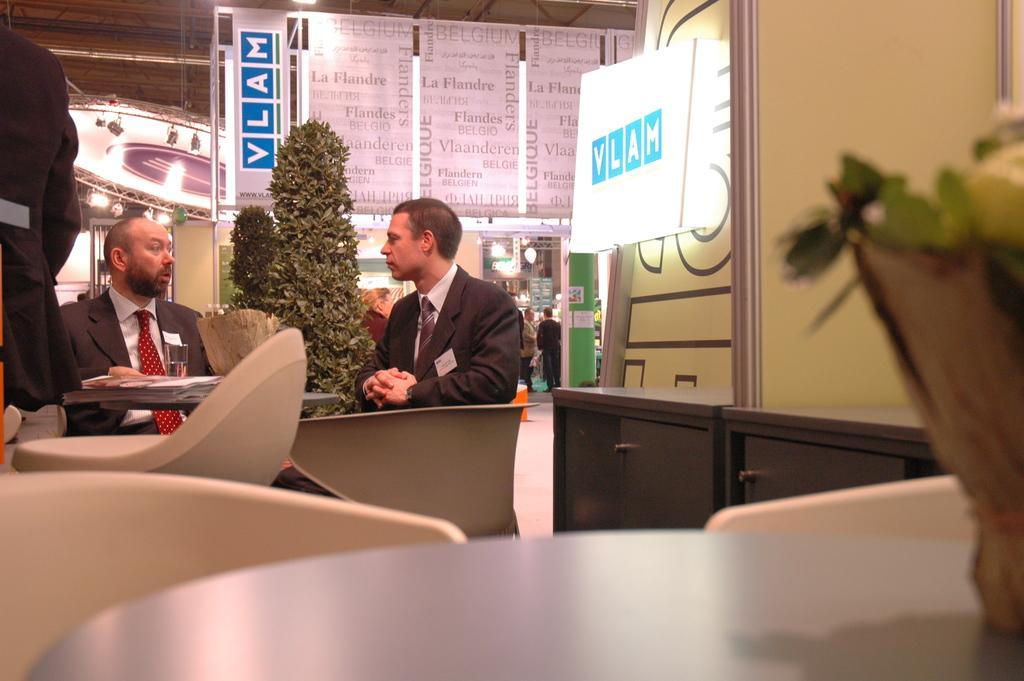Could you give a brief overview of what you see in this image? These two persons are sitting on the chairs and this person standing. We can see chairs and some objects on tables. On the background we can see persons,lights,plant and boards. 